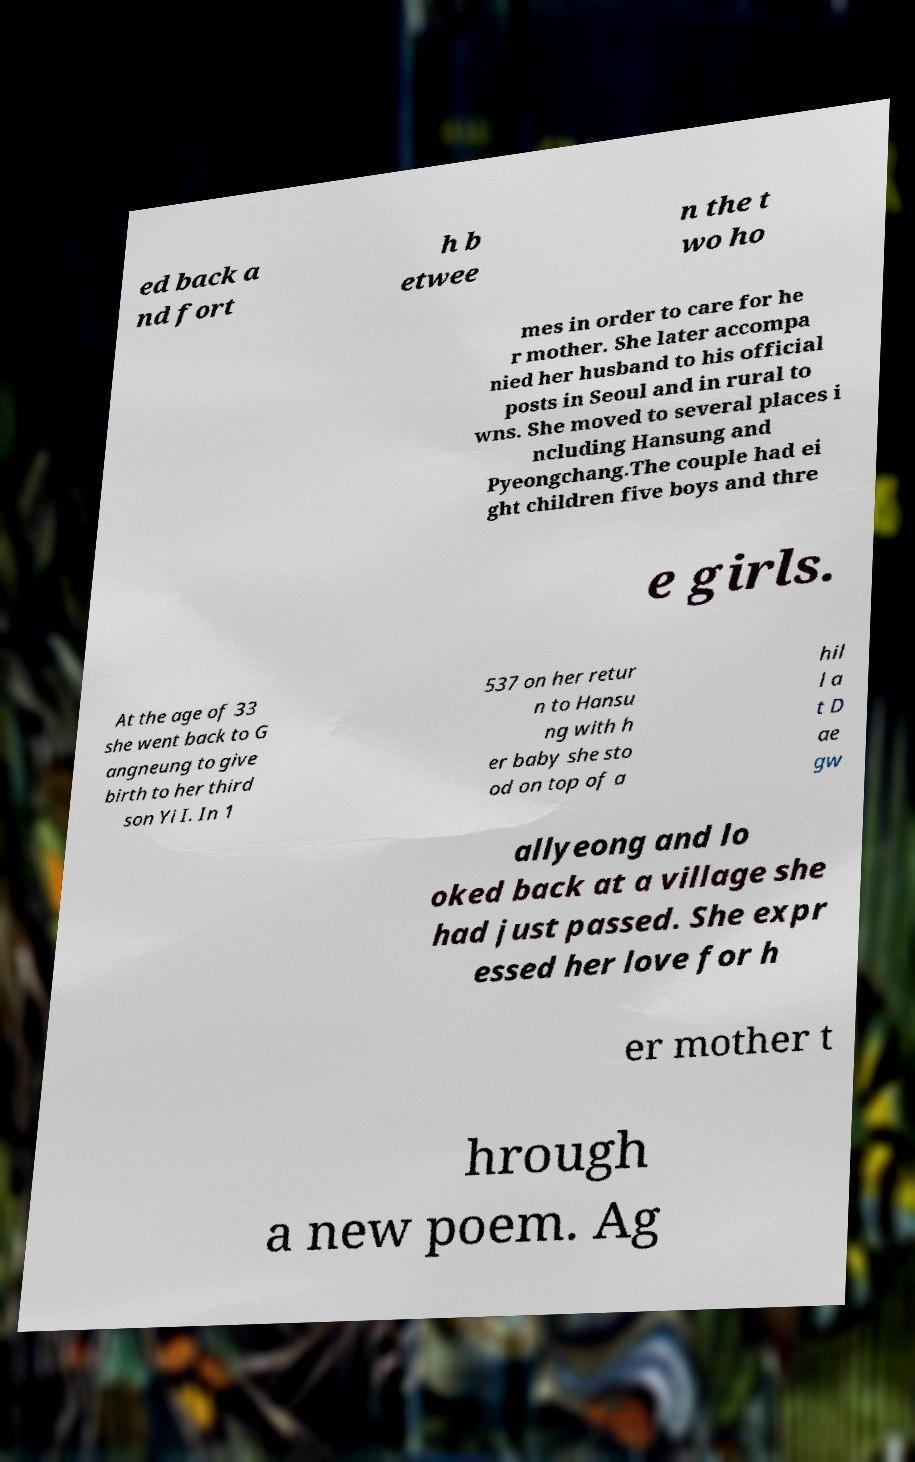I need the written content from this picture converted into text. Can you do that? ed back a nd fort h b etwee n the t wo ho mes in order to care for he r mother. She later accompa nied her husband to his official posts in Seoul and in rural to wns. She moved to several places i ncluding Hansung and Pyeongchang.The couple had ei ght children five boys and thre e girls. At the age of 33 she went back to G angneung to give birth to her third son Yi I. In 1 537 on her retur n to Hansu ng with h er baby she sto od on top of a hil l a t D ae gw allyeong and lo oked back at a village she had just passed. She expr essed her love for h er mother t hrough a new poem. Ag 